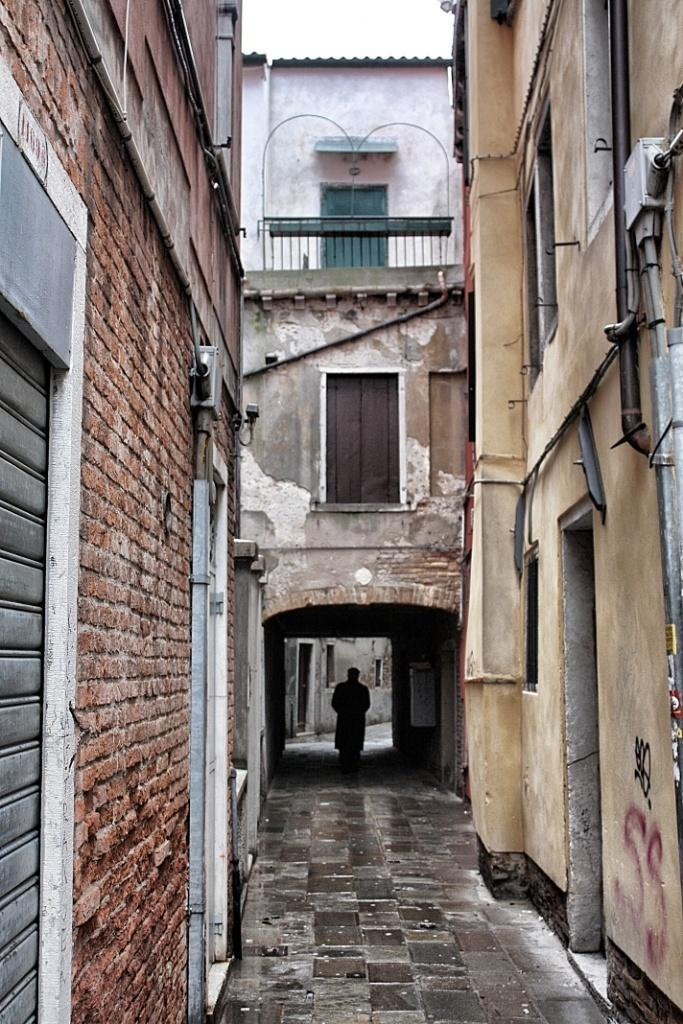What is present in the lane in the image? There is a person in the lane in the image. What can be seen in the background of the image? There are buildings in the image. What is located on the left side of the image? There is a shutter on the left side of the image. What type of structures are visible in the image? There are pipes and red brick walls visible in the image. What type of barrier is present in the image? There is a fence in the image. How many units of corn are visible in the image? There is no corn present in the image. What type of snails can be seen crawling on the red brick walls in the image? There are no snails visible in the image. 